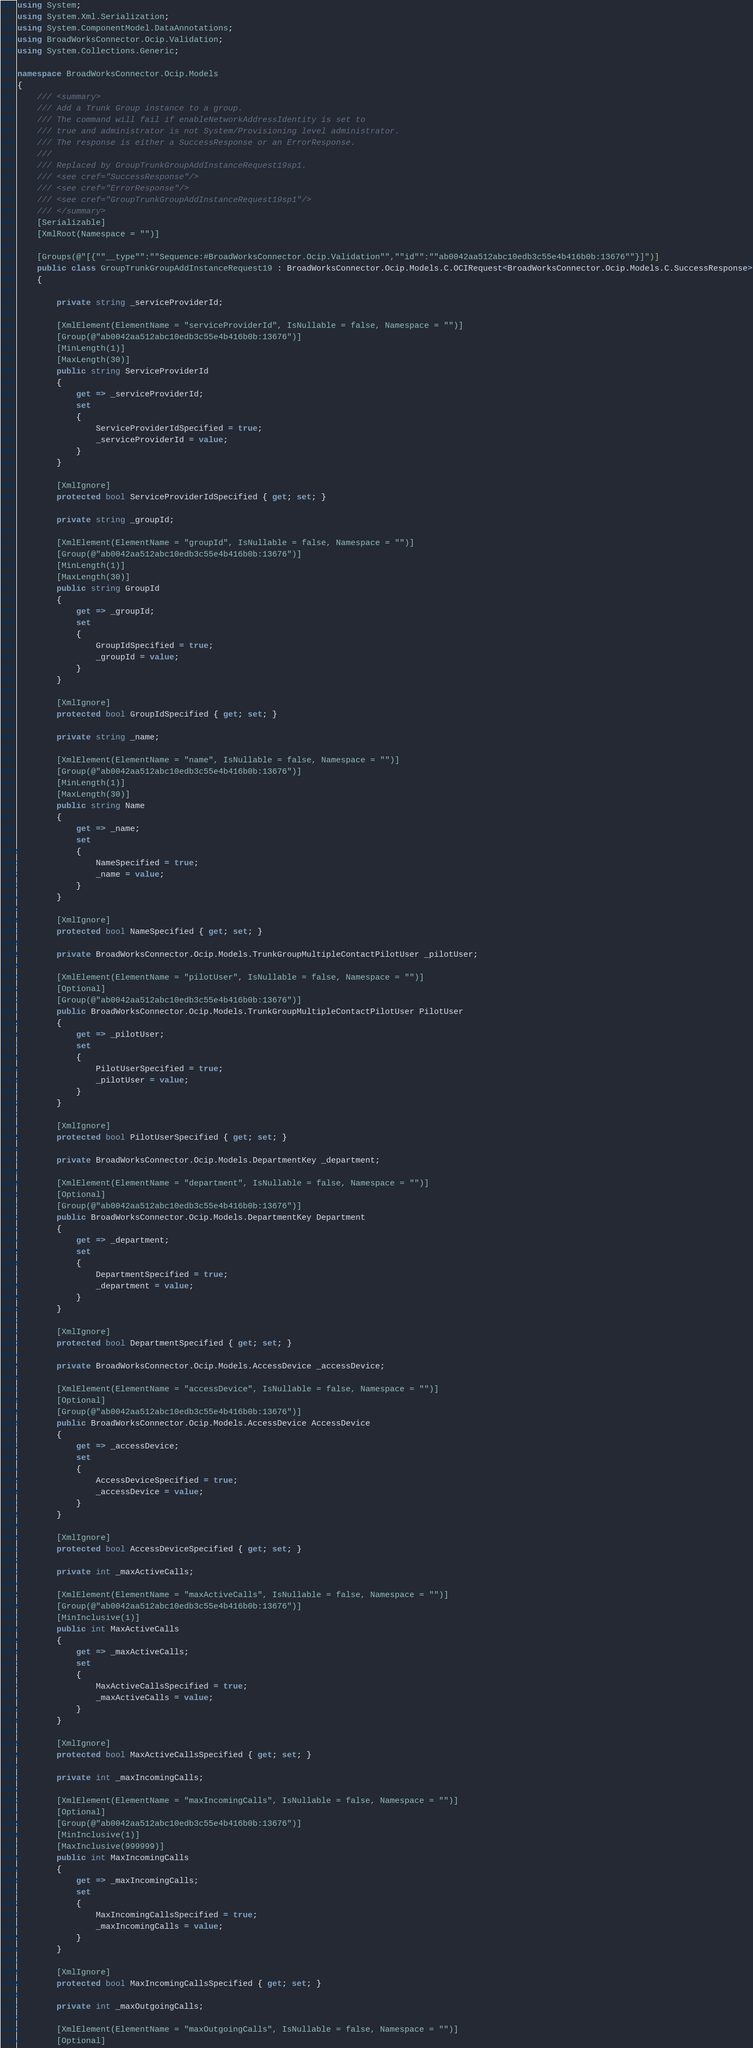<code> <loc_0><loc_0><loc_500><loc_500><_C#_>using System;
using System.Xml.Serialization;
using System.ComponentModel.DataAnnotations;
using BroadWorksConnector.Ocip.Validation;
using System.Collections.Generic;

namespace BroadWorksConnector.Ocip.Models
{
    /// <summary>
    /// Add a Trunk Group instance to a group.
    /// The command will fail if enableNetworkAddressIdentity is set to
    /// true and administrator is not System/Provisioning level administrator.
    /// The response is either a SuccessResponse or an ErrorResponse.
    /// 
    /// Replaced by GroupTrunkGroupAddInstanceRequest19sp1.
    /// <see cref="SuccessResponse"/>
    /// <see cref="ErrorResponse"/>
    /// <see cref="GroupTrunkGroupAddInstanceRequest19sp1"/>
    /// </summary>
    [Serializable]
    [XmlRoot(Namespace = "")]

    [Groups(@"[{""__type"":""Sequence:#BroadWorksConnector.Ocip.Validation"",""id"":""ab0042aa512abc10edb3c55e4b416b0b:13676""}]")]
    public class GroupTrunkGroupAddInstanceRequest19 : BroadWorksConnector.Ocip.Models.C.OCIRequest<BroadWorksConnector.Ocip.Models.C.SuccessResponse>
    {

        private string _serviceProviderId;

        [XmlElement(ElementName = "serviceProviderId", IsNullable = false, Namespace = "")]
        [Group(@"ab0042aa512abc10edb3c55e4b416b0b:13676")]
        [MinLength(1)]
        [MaxLength(30)]
        public string ServiceProviderId
        {
            get => _serviceProviderId;
            set
            {
                ServiceProviderIdSpecified = true;
                _serviceProviderId = value;
            }
        }

        [XmlIgnore]
        protected bool ServiceProviderIdSpecified { get; set; }

        private string _groupId;

        [XmlElement(ElementName = "groupId", IsNullable = false, Namespace = "")]
        [Group(@"ab0042aa512abc10edb3c55e4b416b0b:13676")]
        [MinLength(1)]
        [MaxLength(30)]
        public string GroupId
        {
            get => _groupId;
            set
            {
                GroupIdSpecified = true;
                _groupId = value;
            }
        }

        [XmlIgnore]
        protected bool GroupIdSpecified { get; set; }

        private string _name;

        [XmlElement(ElementName = "name", IsNullable = false, Namespace = "")]
        [Group(@"ab0042aa512abc10edb3c55e4b416b0b:13676")]
        [MinLength(1)]
        [MaxLength(30)]
        public string Name
        {
            get => _name;
            set
            {
                NameSpecified = true;
                _name = value;
            }
        }

        [XmlIgnore]
        protected bool NameSpecified { get; set; }

        private BroadWorksConnector.Ocip.Models.TrunkGroupMultipleContactPilotUser _pilotUser;

        [XmlElement(ElementName = "pilotUser", IsNullable = false, Namespace = "")]
        [Optional]
        [Group(@"ab0042aa512abc10edb3c55e4b416b0b:13676")]
        public BroadWorksConnector.Ocip.Models.TrunkGroupMultipleContactPilotUser PilotUser
        {
            get => _pilotUser;
            set
            {
                PilotUserSpecified = true;
                _pilotUser = value;
            }
        }

        [XmlIgnore]
        protected bool PilotUserSpecified { get; set; }

        private BroadWorksConnector.Ocip.Models.DepartmentKey _department;

        [XmlElement(ElementName = "department", IsNullable = false, Namespace = "")]
        [Optional]
        [Group(@"ab0042aa512abc10edb3c55e4b416b0b:13676")]
        public BroadWorksConnector.Ocip.Models.DepartmentKey Department
        {
            get => _department;
            set
            {
                DepartmentSpecified = true;
                _department = value;
            }
        }

        [XmlIgnore]
        protected bool DepartmentSpecified { get; set; }

        private BroadWorksConnector.Ocip.Models.AccessDevice _accessDevice;

        [XmlElement(ElementName = "accessDevice", IsNullable = false, Namespace = "")]
        [Optional]
        [Group(@"ab0042aa512abc10edb3c55e4b416b0b:13676")]
        public BroadWorksConnector.Ocip.Models.AccessDevice AccessDevice
        {
            get => _accessDevice;
            set
            {
                AccessDeviceSpecified = true;
                _accessDevice = value;
            }
        }

        [XmlIgnore]
        protected bool AccessDeviceSpecified { get; set; }

        private int _maxActiveCalls;

        [XmlElement(ElementName = "maxActiveCalls", IsNullable = false, Namespace = "")]
        [Group(@"ab0042aa512abc10edb3c55e4b416b0b:13676")]
        [MinInclusive(1)]
        public int MaxActiveCalls
        {
            get => _maxActiveCalls;
            set
            {
                MaxActiveCallsSpecified = true;
                _maxActiveCalls = value;
            }
        }

        [XmlIgnore]
        protected bool MaxActiveCallsSpecified { get; set; }

        private int _maxIncomingCalls;

        [XmlElement(ElementName = "maxIncomingCalls", IsNullable = false, Namespace = "")]
        [Optional]
        [Group(@"ab0042aa512abc10edb3c55e4b416b0b:13676")]
        [MinInclusive(1)]
        [MaxInclusive(999999)]
        public int MaxIncomingCalls
        {
            get => _maxIncomingCalls;
            set
            {
                MaxIncomingCallsSpecified = true;
                _maxIncomingCalls = value;
            }
        }

        [XmlIgnore]
        protected bool MaxIncomingCallsSpecified { get; set; }

        private int _maxOutgoingCalls;

        [XmlElement(ElementName = "maxOutgoingCalls", IsNullable = false, Namespace = "")]
        [Optional]</code> 